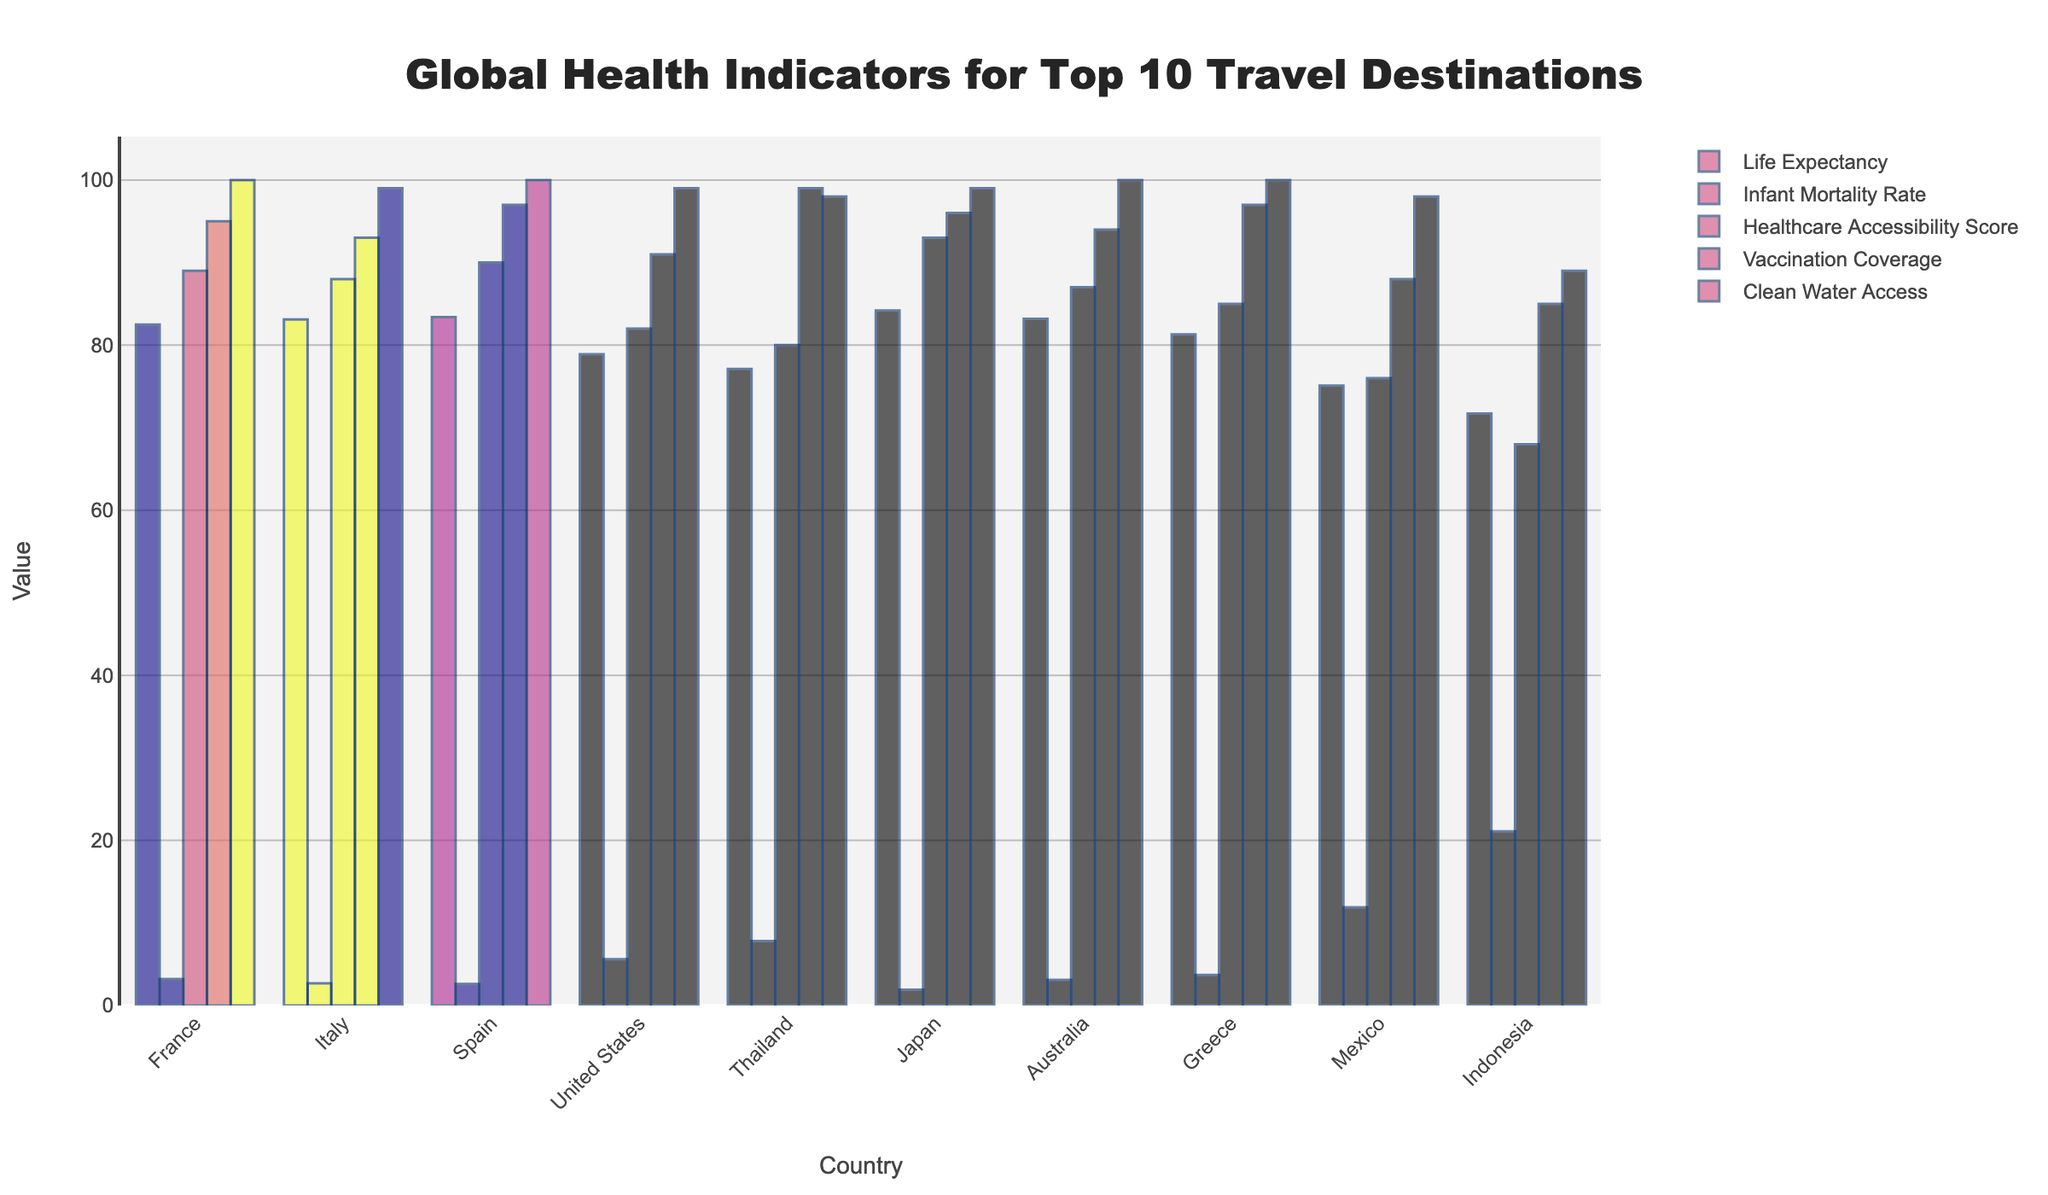Which country has the highest life expectancy? Looking at the "Life Expectancy" category, Japan has the highest value at 84.2.
Answer: Japan What is the difference in infant mortality rate between the United States and Indonesia? The United States has an infant mortality rate of 5.6, and Indonesia has 21.1. The difference is 21.1 - 5.6 = 15.5.
Answer: 15.5 Which country has the lowest healthcare accessibility score? In the "Healthcare Accessibility Score" category, Indonesia has the lowest score at 68.
Answer: Indonesia How does the vaccination coverage of Thailand compare to that of Spain? Thailand has a vaccination coverage of 99, while Spain has 97. 99 is greater than 97.
Answer: Thailand has higher coverage Which country has better access to clean water, Italy or Mexico? Italy has 99 for clean water access, whereas Mexico has 98.
Answer: Italy Which three countries have the top life expectancy rates? Looking at the "Life Expectancy" values, the top three are Japan (84.2), Spain (83.4), and Italy (83.1).
Answer: Japan, Spain, Italy How does the clean water access in Greece compare to that in Australia? Both Greece and Australia have full clean water access, indicated by their value of 100.
Answer: They are equal What is the average healthcare accessibility score of France, Italy, and Spain? France has 89, Italy has 88, and Spain has 90. The average is (89 + 88 + 90)/3 = 267/3 = 89.
Answer: 89 Which country has a bigger gap between life expectancy and infant mortality rate, Mexico or Thailand? Calculate the gap for both countries: Mexico is 75.1 - 11.9 = 63.2, and Thailand is 77.1 - 7.8 = 69.3. Thailand has a bigger gap.
Answer: Thailand By how much does Japan's infant mortality rate differ from France's? Japan's infant mortality rate is 1.9, and France's is 3.2. The difference is 3.2 - 1.9 = 1.3.
Answer: 1.3 